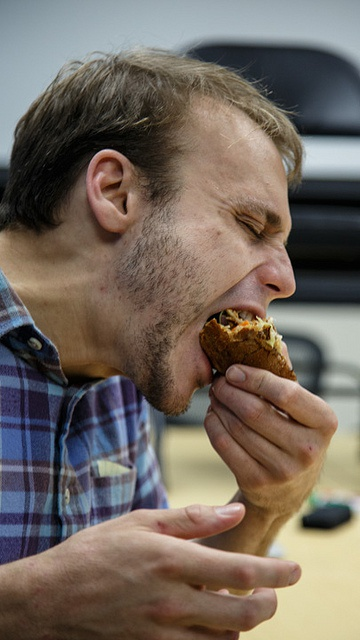Describe the objects in this image and their specific colors. I can see people in gray, black, and maroon tones, chair in gray, black, and lightgray tones, truck in gray, black, and lightgray tones, sandwich in gray, black, maroon, and olive tones, and pizza in gray, maroon, black, and olive tones in this image. 